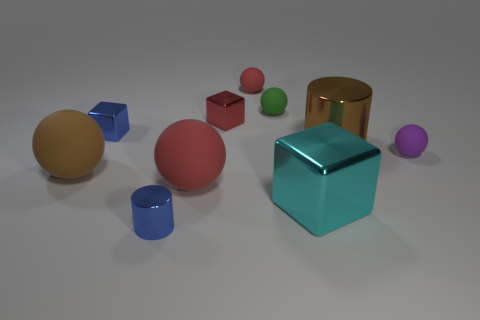Subtract all small blocks. How many blocks are left? 1 Subtract all green cubes. How many red spheres are left? 2 Subtract all green spheres. How many spheres are left? 4 Subtract 5 balls. How many balls are left? 0 Subtract all cylinders. How many objects are left? 8 Add 2 brown cylinders. How many brown cylinders are left? 3 Add 9 green rubber spheres. How many green rubber spheres exist? 10 Subtract 1 purple spheres. How many objects are left? 9 Subtract all red balls. Subtract all green cubes. How many balls are left? 3 Subtract all small brown rubber balls. Subtract all small red balls. How many objects are left? 9 